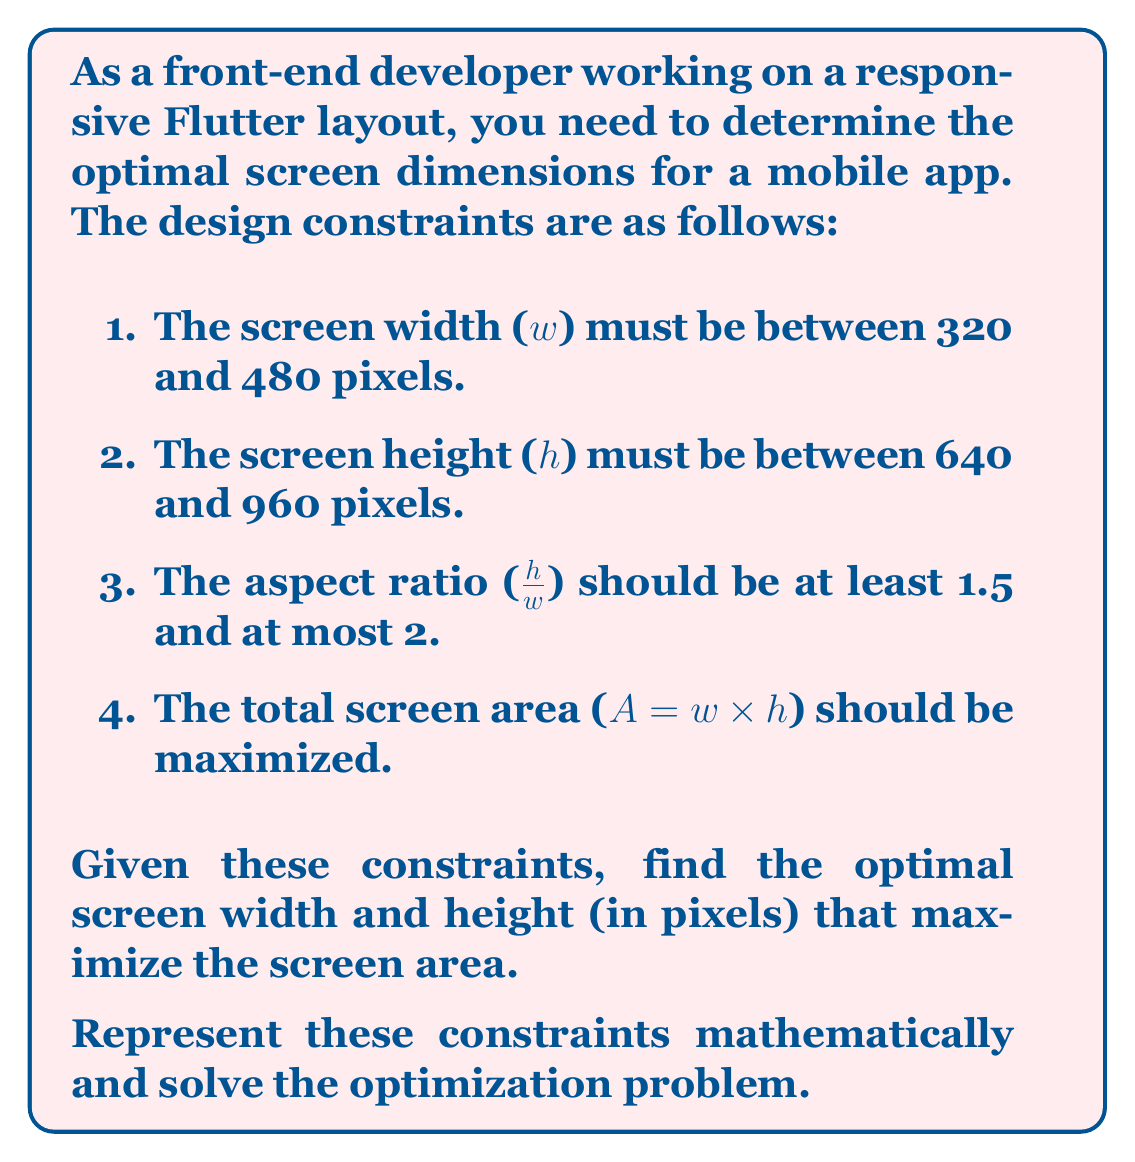Provide a solution to this math problem. Let's approach this step-by-step:

1) First, we'll express the constraints mathematically:

   $320 \leq w \leq 480$
   $640 \leq h \leq 960$
   $1.5 \leq \frac{h}{w} \leq 2$

2) The objective function to maximize is:

   $A = w \times h$

3) From the aspect ratio constraint, we can derive:

   $1.5w \leq h \leq 2w$

4) Combining this with the height constraint:

   $\max(640, 1.5w) \leq h \leq \min(960, 2w)$

5) To maximize area, we want both $w$ and $h$ to be as large as possible while satisfying all constraints.

6) The maximum possible width is 480 pixels. Let's check if this satisfies all constraints:

   If $w = 480$:
   $1.5 \times 480 = 720 \leq h \leq 960$

   This satisfies all constraints, so we can use the maximum width.

7) Now, for $h$, we want the largest value that satisfies:

   $720 \leq h \leq 960$

   The maximum value is 960.

8) Let's verify the aspect ratio:

   $\frac{960}{480} = 2$, which satisfies $1.5 \leq \frac{h}{w} \leq 2$

9) Therefore, the optimal dimensions are:
   $w = 480$ pixels
   $h = 960$ pixels

10) The maximum area is:
    $A = 480 \times 960 = 460,800$ square pixels
Answer: The optimal screen dimensions are:
Width: 480 pixels
Height: 960 pixels
Maximum Area: 460,800 square pixels 